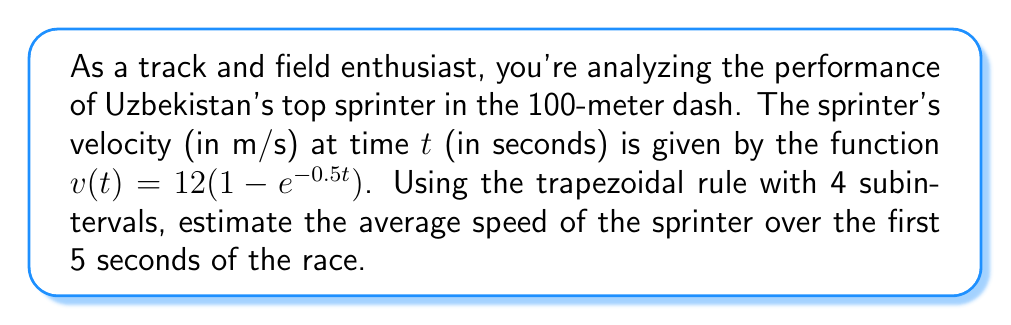Show me your answer to this math problem. To estimate the average speed using numerical integration, we'll follow these steps:

1) The average speed is the total distance traveled divided by the time taken. We can calculate the distance by integrating the velocity function.

2) We need to use the trapezoidal rule to approximate the integral of $v(t)$ from 0 to 5 seconds.

3) The trapezoidal rule formula for 4 subintervals is:

   $$\int_{0}^{5} v(t) dt \approx \frac{h}{2}[f(x_0) + 2f(x_1) + 2f(x_2) + 2f(x_3) + f(x_4)]$$

   where $h = \frac{b-a}{n} = \frac{5-0}{4} = 1.25$ seconds

4) Calculate $v(t)$ at $t = 0, 1.25, 2.5, 3.75,$ and $5$ seconds:

   $v(0) = 12(1 - e^{-0.5(0)}) = 0$
   $v(1.25) = 12(1 - e^{-0.5(1.25)}) \approx 6.11$
   $v(2.5) = 12(1 - e^{-0.5(2.5)}) \approx 8.96$
   $v(3.75) = 12(1 - e^{-0.5(3.75)}) \approx 10.44$
   $v(5) = 12(1 - e^{-0.5(5)}) \approx 11.16$

5) Apply the trapezoidal rule:

   $$\text{Distance} \approx \frac{1.25}{2}[0 + 2(6.11) + 2(8.96) + 2(10.44) + 11.16]$$
   $$\approx 0.625[0 + 12.22 + 17.92 + 20.88 + 11.16]$$
   $$\approx 0.625(62.18) \approx 38.86 \text{ meters}$$

6) Calculate the average speed:

   $$\text{Average Speed} = \frac{\text{Distance}}{\text{Time}} = \frac{38.86 \text{ m}}{5 \text{ s}} \approx 7.77 \text{ m/s}$$
Answer: 7.77 m/s 